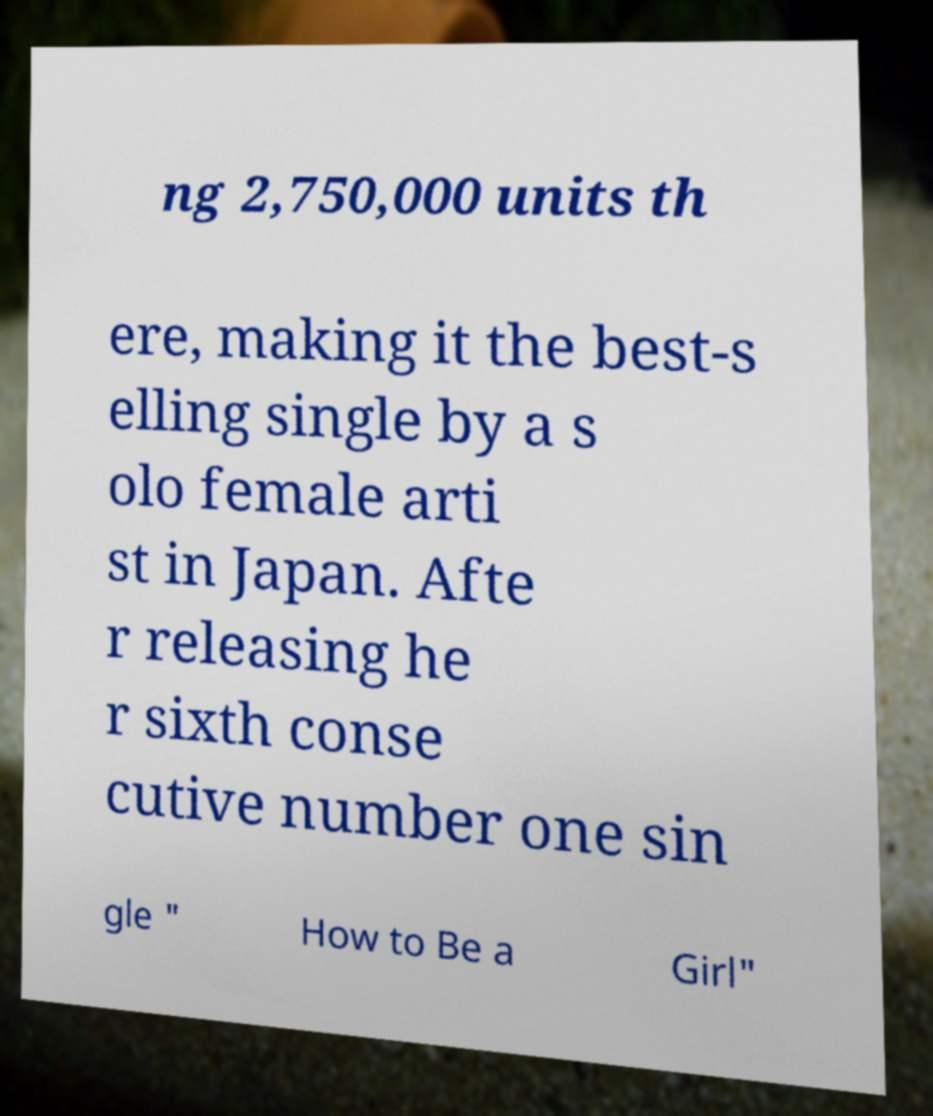What messages or text are displayed in this image? I need them in a readable, typed format. ng 2,750,000 units th ere, making it the best-s elling single by a s olo female arti st in Japan. Afte r releasing he r sixth conse cutive number one sin gle " How to Be a Girl" 